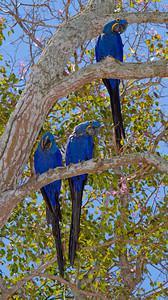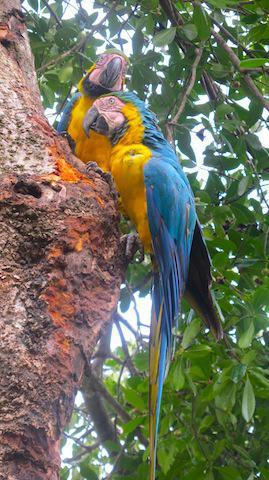The first image is the image on the left, the second image is the image on the right. Analyze the images presented: Is the assertion "One image includes a red-headed bird and a bird with blue-and-yellow coloring." valid? Answer yes or no. No. 